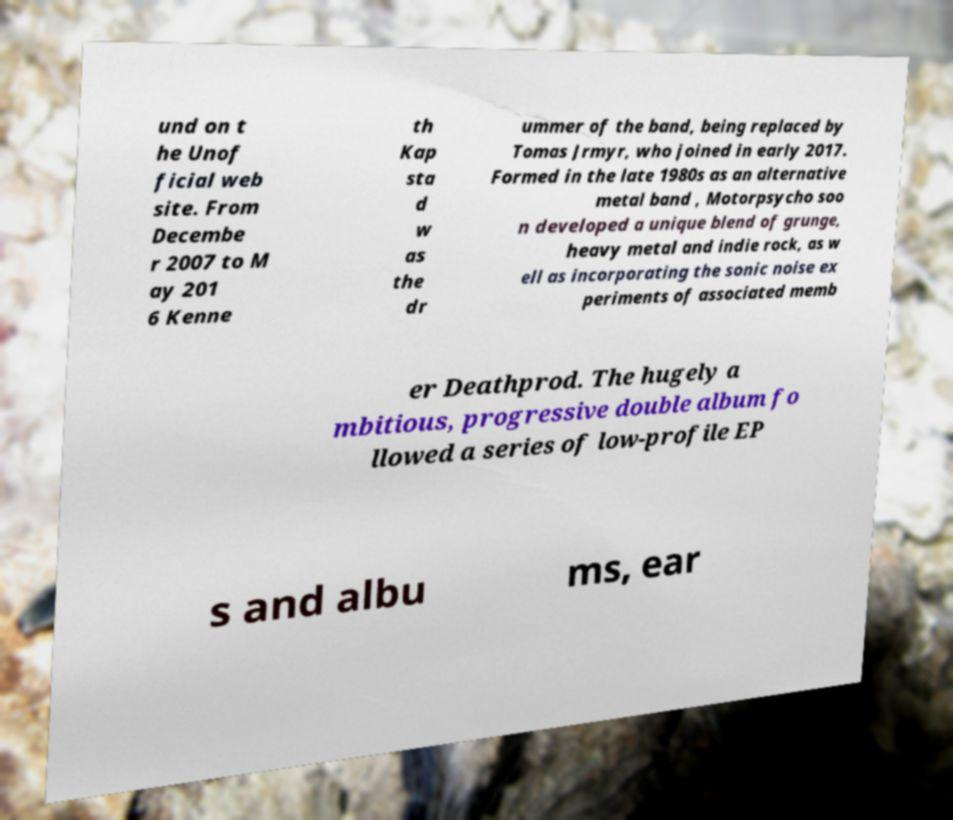Can you accurately transcribe the text from the provided image for me? und on t he Unof ficial web site. From Decembe r 2007 to M ay 201 6 Kenne th Kap sta d w as the dr ummer of the band, being replaced by Tomas Jrmyr, who joined in early 2017. Formed in the late 1980s as an alternative metal band , Motorpsycho soo n developed a unique blend of grunge, heavy metal and indie rock, as w ell as incorporating the sonic noise ex periments of associated memb er Deathprod. The hugely a mbitious, progressive double album fo llowed a series of low-profile EP s and albu ms, ear 